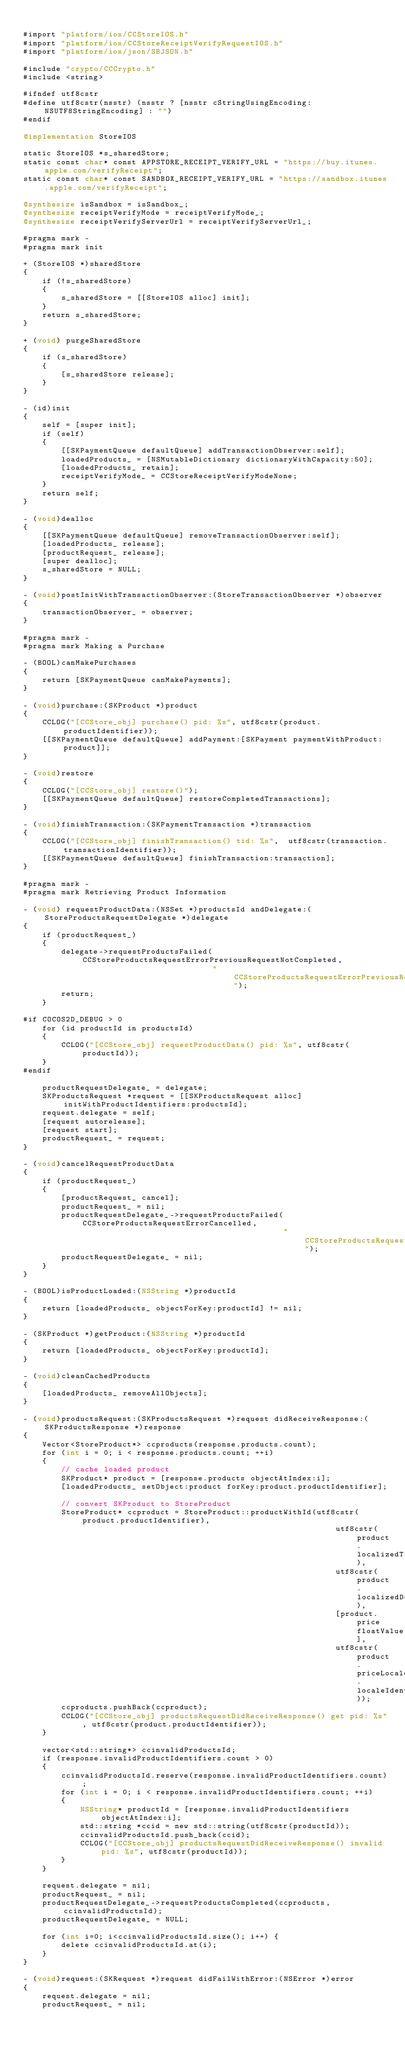Convert code to text. <code><loc_0><loc_0><loc_500><loc_500><_ObjectiveC_>
#import "platform/ios/CCStoreIOS.h"
#import "platform/ios/CCStoreReceiptVerifyRequestIOS.h"
#import "platform/ios/json/SBJSON.h"

#include "crypto/CCCrypto.h"
#include <string>

#ifndef utf8cstr
#define utf8cstr(nsstr) (nsstr ? [nsstr cStringUsingEncoding:NSUTF8StringEncoding] : "")
#endif

@implementation StoreIOS

static StoreIOS *s_sharedStore;
static const char* const APPSTORE_RECEIPT_VERIFY_URL = "https://buy.itunes.apple.com/verifyReceipt";
static const char* const SANDBOX_RECEIPT_VERIFY_URL = "https://sandbox.itunes.apple.com/verifyReceipt";

@synthesize isSandbox = isSandbox_;
@synthesize receiptVerifyMode = receiptVerifyMode_;
@synthesize receiptVerifyServerUrl = receiptVerifyServerUrl_;

#pragma mark -
#pragma mark init

+ (StoreIOS *)sharedStore
{
    if (!s_sharedStore)
    {
        s_sharedStore = [[StoreIOS alloc] init];
    }
    return s_sharedStore;
}

+ (void) purgeSharedStore
{
    if (s_sharedStore)
    {
        [s_sharedStore release];
    }
}

- (id)init
{
    self = [super init];
    if (self)
    {
        [[SKPaymentQueue defaultQueue] addTransactionObserver:self];
        loadedProducts_ = [NSMutableDictionary dictionaryWithCapacity:50];
        [loadedProducts_ retain];
        receiptVerifyMode_ = CCStoreReceiptVerifyModeNone;
    }
    return self;
}

- (void)dealloc
{
    [[SKPaymentQueue defaultQueue] removeTransactionObserver:self];
    [loadedProducts_ release];
    [productRequest_ release];
    [super dealloc];
    s_sharedStore = NULL;
}

- (void)postInitWithTransactionObserver:(StoreTransactionObserver *)observer
{
    transactionObserver_ = observer;
}

#pragma mark -
#pragma mark Making a Purchase

- (BOOL)canMakePurchases
{
    return [SKPaymentQueue canMakePayments];
}

- (void)purchase:(SKProduct *)product
{
    CCLOG("[CCStore_obj] purchase() pid: %s", utf8cstr(product.productIdentifier));
    [[SKPaymentQueue defaultQueue] addPayment:[SKPayment paymentWithProduct:product]];
}

- (void)restore
{
    CCLOG("[CCStore_obj] restore()");
    [[SKPaymentQueue defaultQueue] restoreCompletedTransactions];
}

- (void)finishTransaction:(SKPaymentTransaction *)transaction
{
    CCLOG("[CCStore_obj] finishTransaction() tid: %s",  utf8cstr(transaction.transactionIdentifier));
    [[SKPaymentQueue defaultQueue] finishTransaction:transaction];
}

#pragma mark -
#pragma mark Retrieving Product Information

- (void) requestProductData:(NSSet *)productsId andDelegate:(StoreProductsRequestDelegate *)delegate
{
    if (productRequest_)
    {
        delegate->requestProductsFailed(CCStoreProductsRequestErrorPreviousRequestNotCompleted,
                                        "CCStoreProductsRequestErrorPreviousRequestNotCompleted");
        return;
    }

#if COCOS2D_DEBUG > 0
    for (id productId in productsId)
    {
        CCLOG("[CCStore_obj] requestProductData() pid: %s", utf8cstr(productId));
    }
#endif

    productRequestDelegate_ = delegate;
    SKProductsRequest *request = [[SKProductsRequest alloc] initWithProductIdentifiers:productsId];
    request.delegate = self;
    [request autorelease];
    [request start];
    productRequest_ = request;
}

- (void)cancelRequestProductData
{
    if (productRequest_)
    {
        [productRequest_ cancel];
        productRequest_ = nil;
        productRequestDelegate_->requestProductsFailed(CCStoreProductsRequestErrorCancelled,
                                                       "CCStoreProductsRequestErrorCancelled");
        productRequestDelegate_ = nil;
    }
}

- (BOOL)isProductLoaded:(NSString *)productId
{
    return [loadedProducts_ objectForKey:productId] != nil;
}

- (SKProduct *)getProduct:(NSString *)productId
{
    return [loadedProducts_ objectForKey:productId];
}

- (void)cleanCachedProducts
{
    [loadedProducts_ removeAllObjects];
}

- (void)productsRequest:(SKProductsRequest *)request didReceiveResponse:(SKProductsResponse *)response
{
    Vector<StoreProduct*> ccproducts(response.products.count);
    for (int i = 0; i < response.products.count; ++i)
    {
        // cache loaded product
        SKProduct* product = [response.products objectAtIndex:i];
        [loadedProducts_ setObject:product forKey:product.productIdentifier];

        // convert SKProduct to StoreProduct
        StoreProduct* ccproduct = StoreProduct::productWithId(utf8cstr(product.productIdentifier),
                                                                  utf8cstr(product.localizedTitle),
                                                                  utf8cstr(product.localizedDescription),
                                                                  [product.price floatValue],
                                                                  utf8cstr(product.priceLocale.localeIdentifier));
        ccproducts.pushBack(ccproduct);
        CCLOG("[CCStore_obj] productsRequestDidReceiveResponse() get pid: %s", utf8cstr(product.productIdentifier));
    }

    vector<std::string*> ccinvalidProductsId;
    if (response.invalidProductIdentifiers.count > 0)
    {
        ccinvalidProductsId.reserve(response.invalidProductIdentifiers.count);
        for (int i = 0; i < response.invalidProductIdentifiers.count; ++i)
        {
            NSString* productId = [response.invalidProductIdentifiers objectAtIndex:i];
            std::string *ccid = new std::string(utf8cstr(productId));
            ccinvalidProductsId.push_back(ccid);
            CCLOG("[CCStore_obj] productsRequestDidReceiveResponse() invalid pid: %s", utf8cstr(productId));
        }
    }

    request.delegate = nil;
    productRequest_ = nil;
    productRequestDelegate_->requestProductsCompleted(ccproducts, ccinvalidProductsId);
    productRequestDelegate_ = NULL;
    
    for (int i=0; i<ccinvalidProductsId.size(); i++) {
        delete ccinvalidProductsId.at(i);
    }
}

- (void)request:(SKRequest *)request didFailWithError:(NSError *)error
{
    request.delegate = nil;
    productRequest_ = nil;</code> 